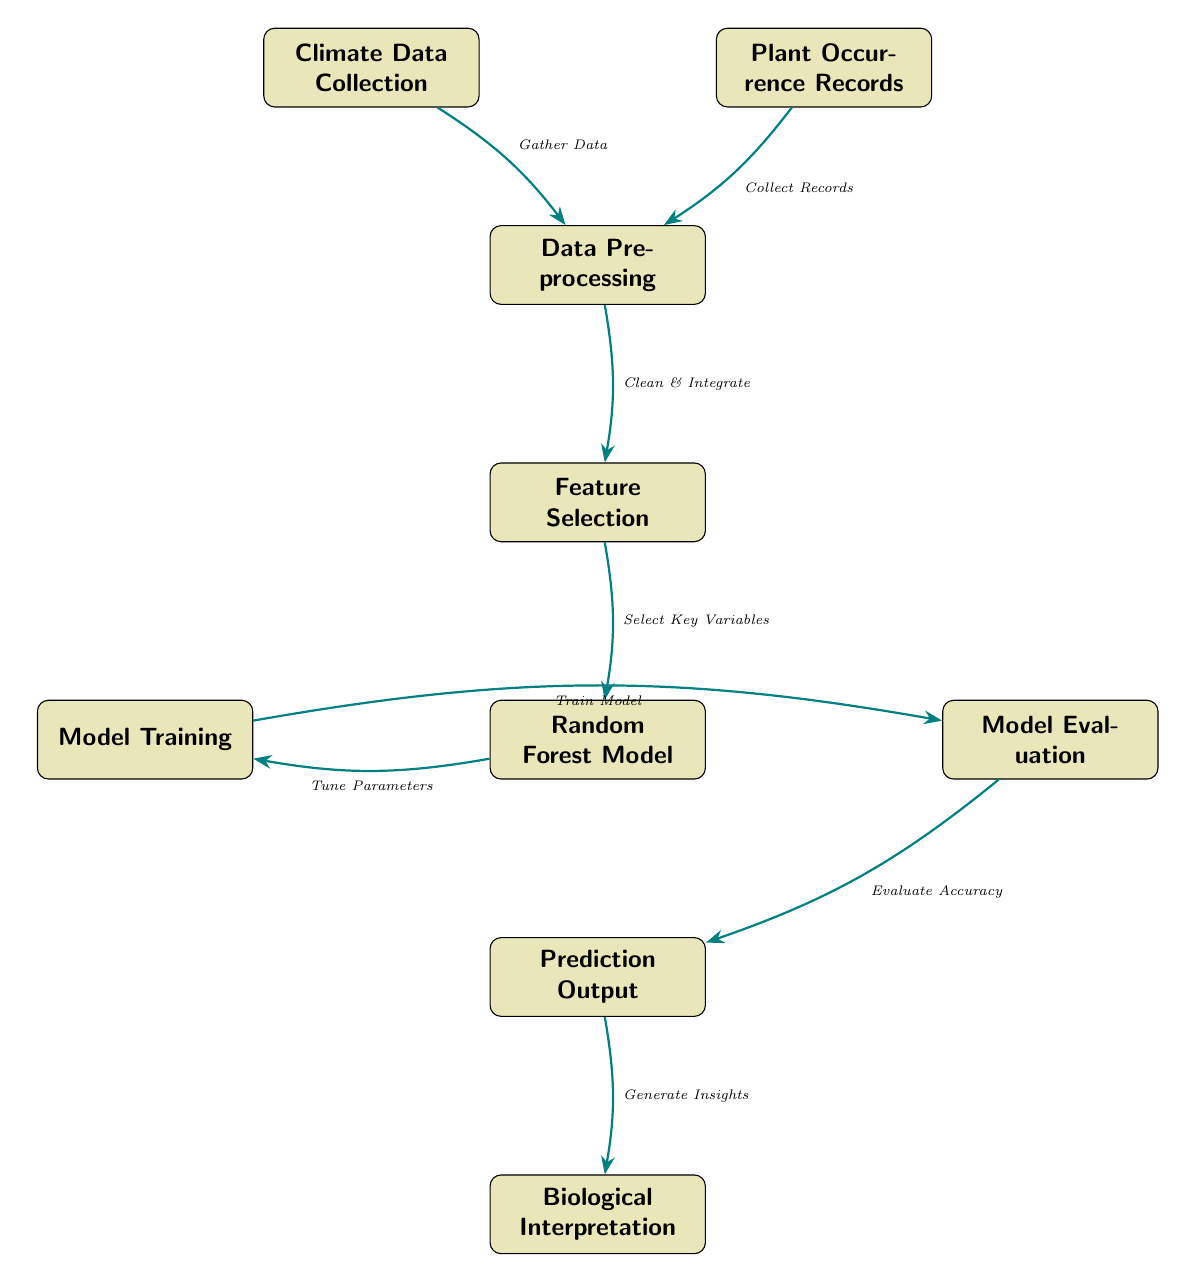What is the first step in the process? The first step in the diagram is "Climate Data Collection," which is at the top-left of the flow. This shows the initial stage where climate data is gathered.
Answer: Climate Data Collection How many nodes are present in the diagram? By counting each distinct step represented in the diagram, there are eight nodes in total, including "Climate Data Collection" and "Biological Interpretation."
Answer: Eight What connects the "Plant Occurrence Records" to "Data Preprocessing"? The connection is established through the label "Collect Records," showing that plant occurrence records are used as data input for preprocessing.
Answer: Collect Records Which node follows "Feature Selection"? The node that follows "Feature Selection" is "Random Forest Model," indicating the progression from selecting features to utilizing them in a model.
Answer: Random Forest Model What is the output of the "Model Evaluation"? The output of "Model Evaluation" is "Prediction Output," denoting that after evaluating the model, predictions are generated.
Answer: Prediction Output What is the relationship between "Random Forest Model" and "Model Training"? The relationship is labeled "Tune Parameters," meaning that tuning model parameters is a part of the model training phase.
Answer: Tune Parameters What is the final step of the process? The final step in the diagram is "Biological Interpretation," which suggests that the predictions made are interpreted in a biological context.
Answer: Biological Interpretation Which step connects climate data and plant occurrence records? The connecting step is "Data Preprocessing," where both climate data and plant occurrence records are integrated before being processed further.
Answer: Data Preprocessing What is the purpose of the "Feature Selection" step? The purpose is described as "Select Key Variables," indicating the focus on choosing the important features for model training.
Answer: Select Key Variables 